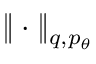<formula> <loc_0><loc_0><loc_500><loc_500>\| \cdot \| _ { q , p _ { \theta } }</formula> 